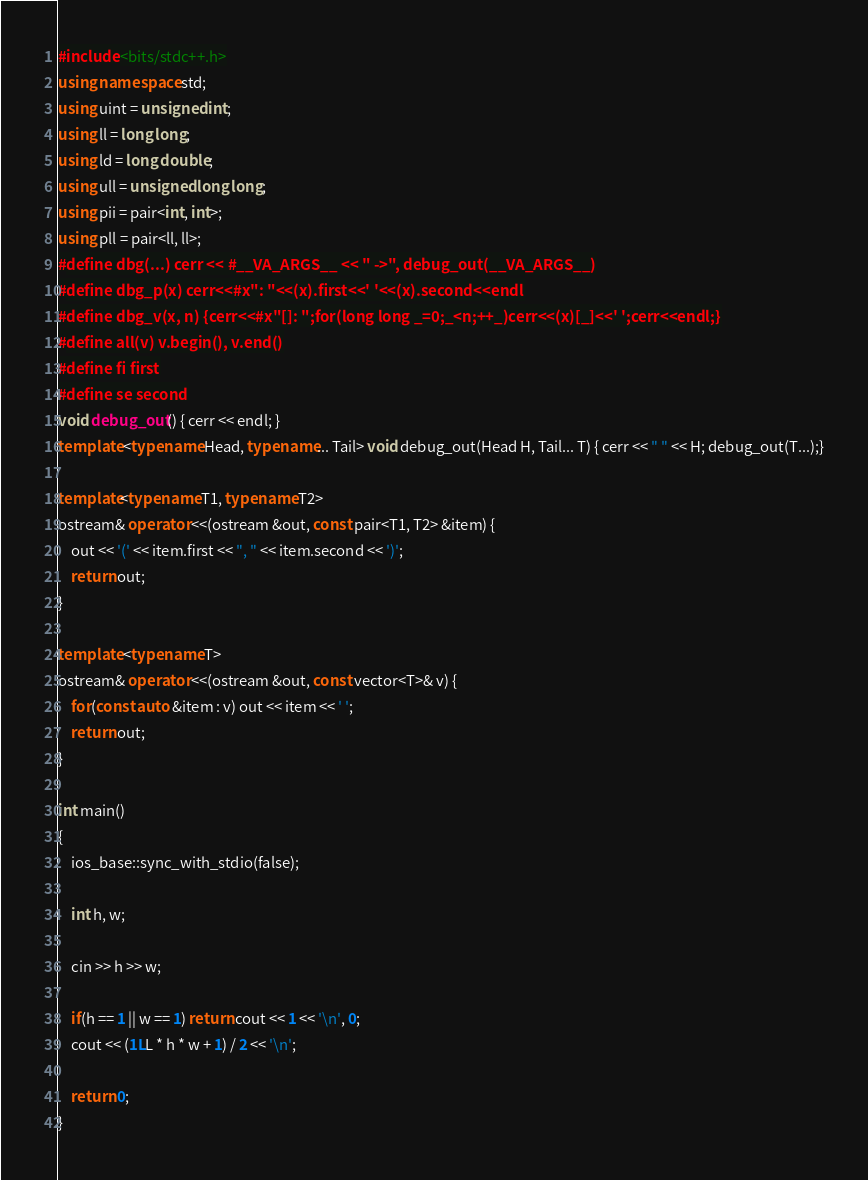Convert code to text. <code><loc_0><loc_0><loc_500><loc_500><_C++_>#include <bits/stdc++.h>
using namespace std;
using uint = unsigned int;
using ll = long long;
using ld = long double;
using ull = unsigned long long;
using pii = pair<int, int>;
using pll = pair<ll, ll>;
#define dbg(...) cerr << #__VA_ARGS__ << " ->", debug_out(__VA_ARGS__)
#define dbg_p(x) cerr<<#x": "<<(x).first<<' '<<(x).second<<endl
#define dbg_v(x, n) {cerr<<#x"[]: ";for(long long _=0;_<n;++_)cerr<<(x)[_]<<' ';cerr<<endl;}
#define all(v) v.begin(), v.end()
#define fi first
#define se second
void debug_out() { cerr << endl; }
template <typename Head, typename... Tail> void debug_out(Head H, Tail... T) { cerr << " " << H; debug_out(T...);}

template<typename T1, typename T2>
ostream& operator <<(ostream &out, const pair<T1, T2> &item) {
	out << '(' << item.first << ", " << item.second << ')';
	return out;
}

template <typename T>
ostream& operator <<(ostream &out, const vector<T>& v) {
	for(const auto &item : v) out << item << ' ';
	return out;
}

int main()
{
	ios_base::sync_with_stdio(false);
	
	int h, w;

	cin >> h >> w;
	
	if(h == 1 || w == 1) return cout << 1 << '\n', 0;
	cout << (1LL * h * w + 1) / 2 << '\n';

	return 0;
}

</code> 